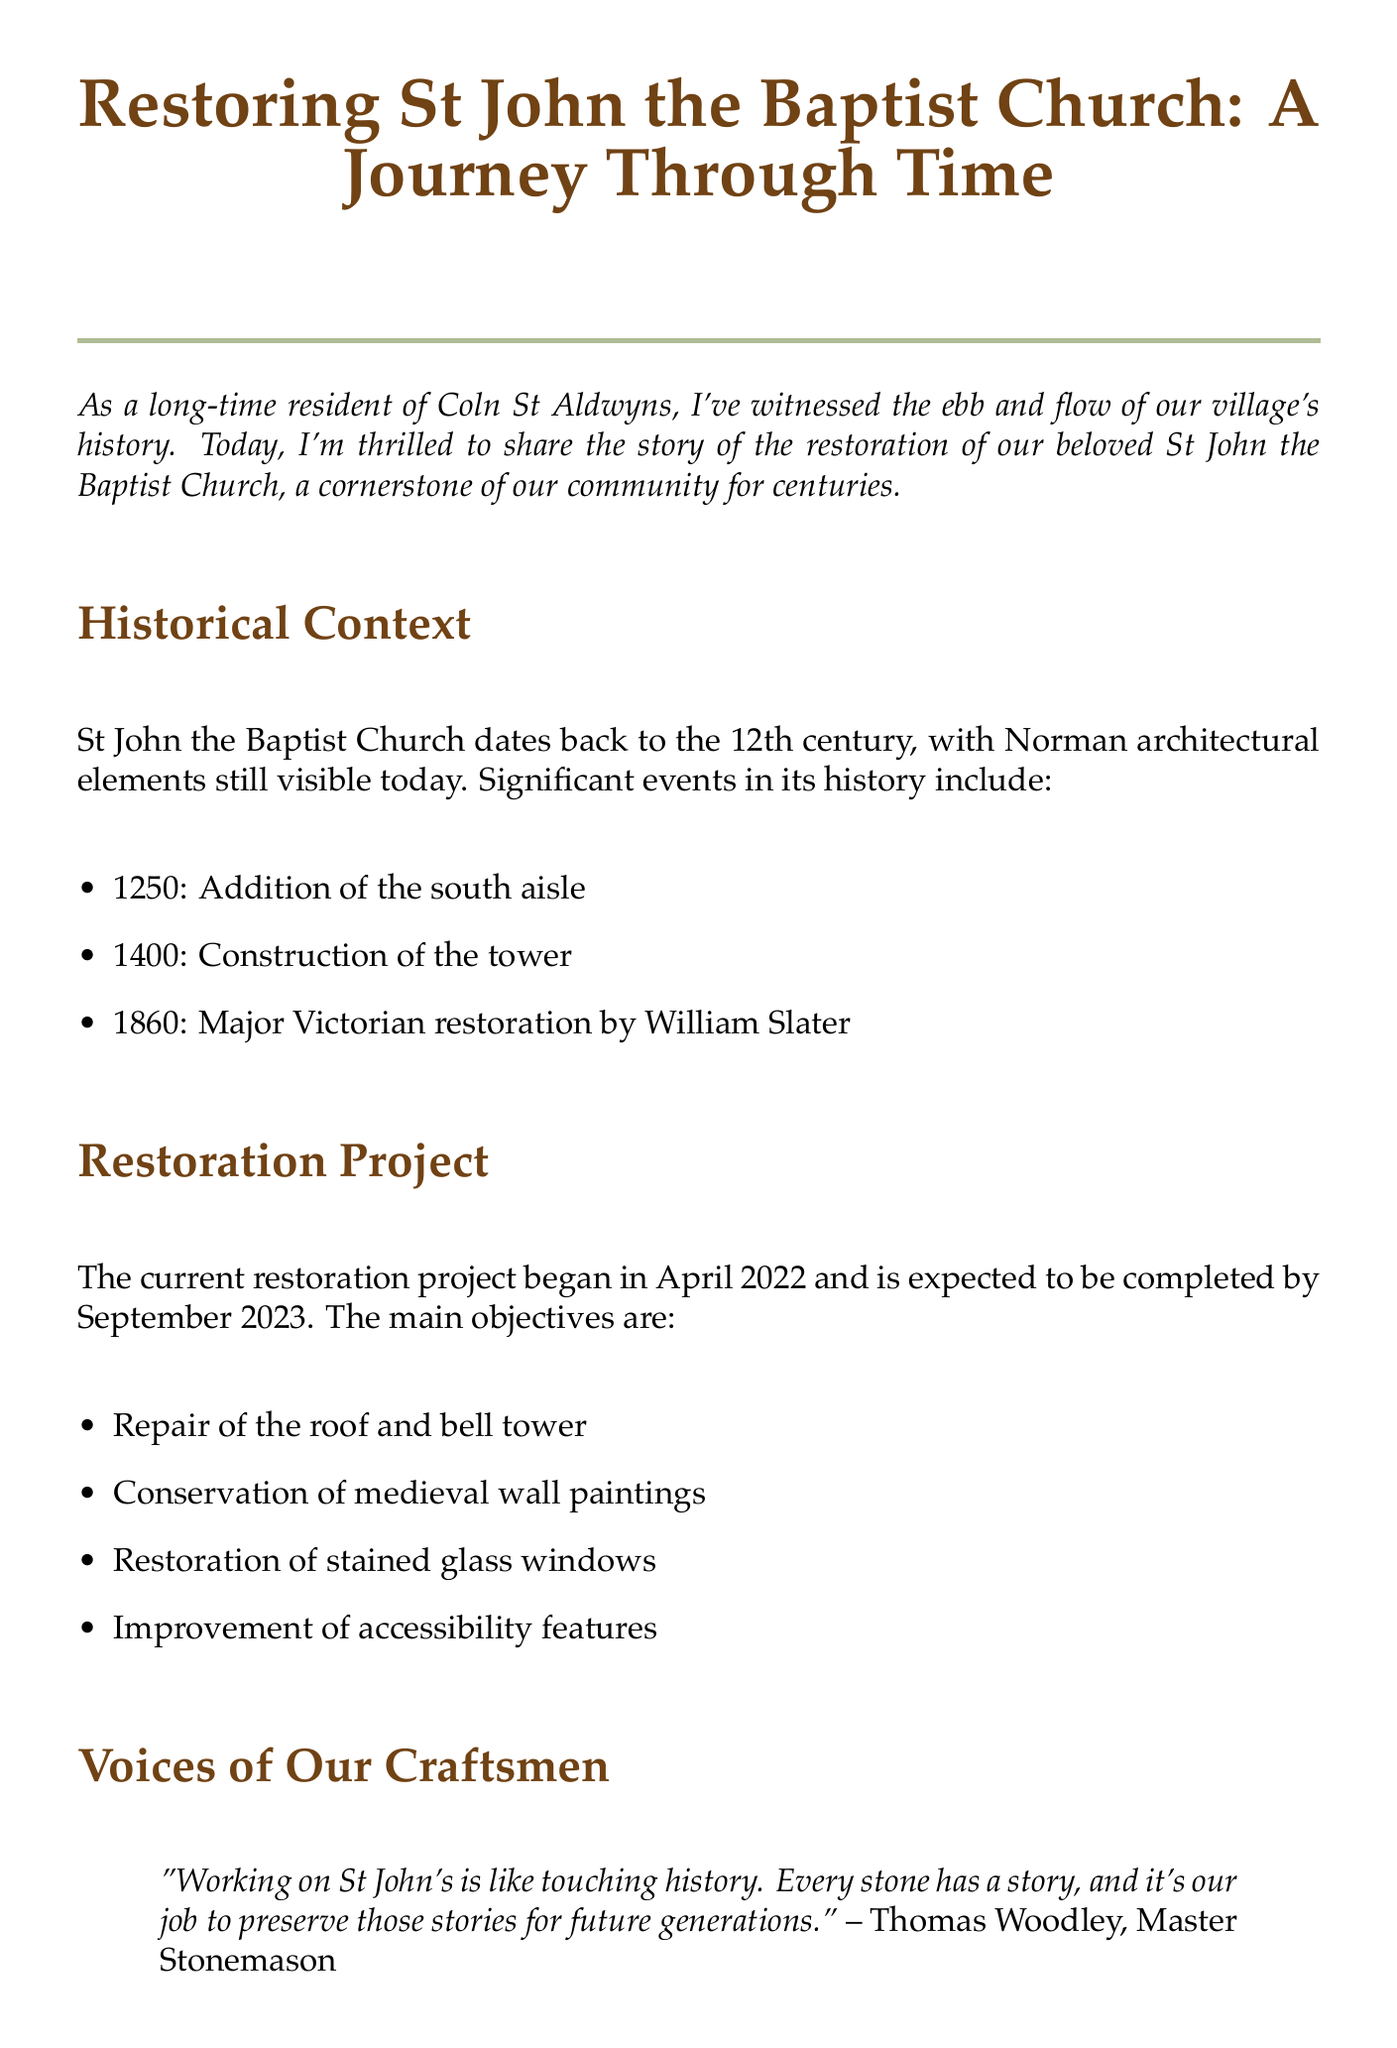What year was the church built? The document states that St John the Baptist Church dates back to the 12th century.
Answer: 12th century What are the main objectives of the restoration project? The document lists several objectives for the restoration project, including repairing the roof and conservation of wall paintings.
Answer: Repair of the roof and bell tower When did the major Victorian restoration occur? The document provides a specific year for the major Victorian restoration of the church, which was by William Slater.
Answer: 1860 Who is the stained glass conservator? The document mentions the name and occupation of the stained glass conservator involved in the restoration.
Answer: Emily Glassworthy What significant event happened in 1400? The document lists important historical events related to the church, including this one.
Answer: Construction of the tower How long did the restoration project last? The document indicates that the project began in April 2022 and was expected to complete in September 2023, allowing calculation of the duration.
Answer: 1 year and 5 months What type of community involvement is mentioned? The document provides examples of community activities associated with the restoration project.
Answer: Fundraising events What does Thomas Woodley say about working on the church? The document includes a quote from Thomas Woodley regarding his feelings about the restoration work.
Answer: "Working on St John's is like touching history." Who should be contacted for volunteering? The document specifies the person to contact for those interested in volunteering or contributing to the restoration fund.
Answer: Mrs. Sarah Chedworth 